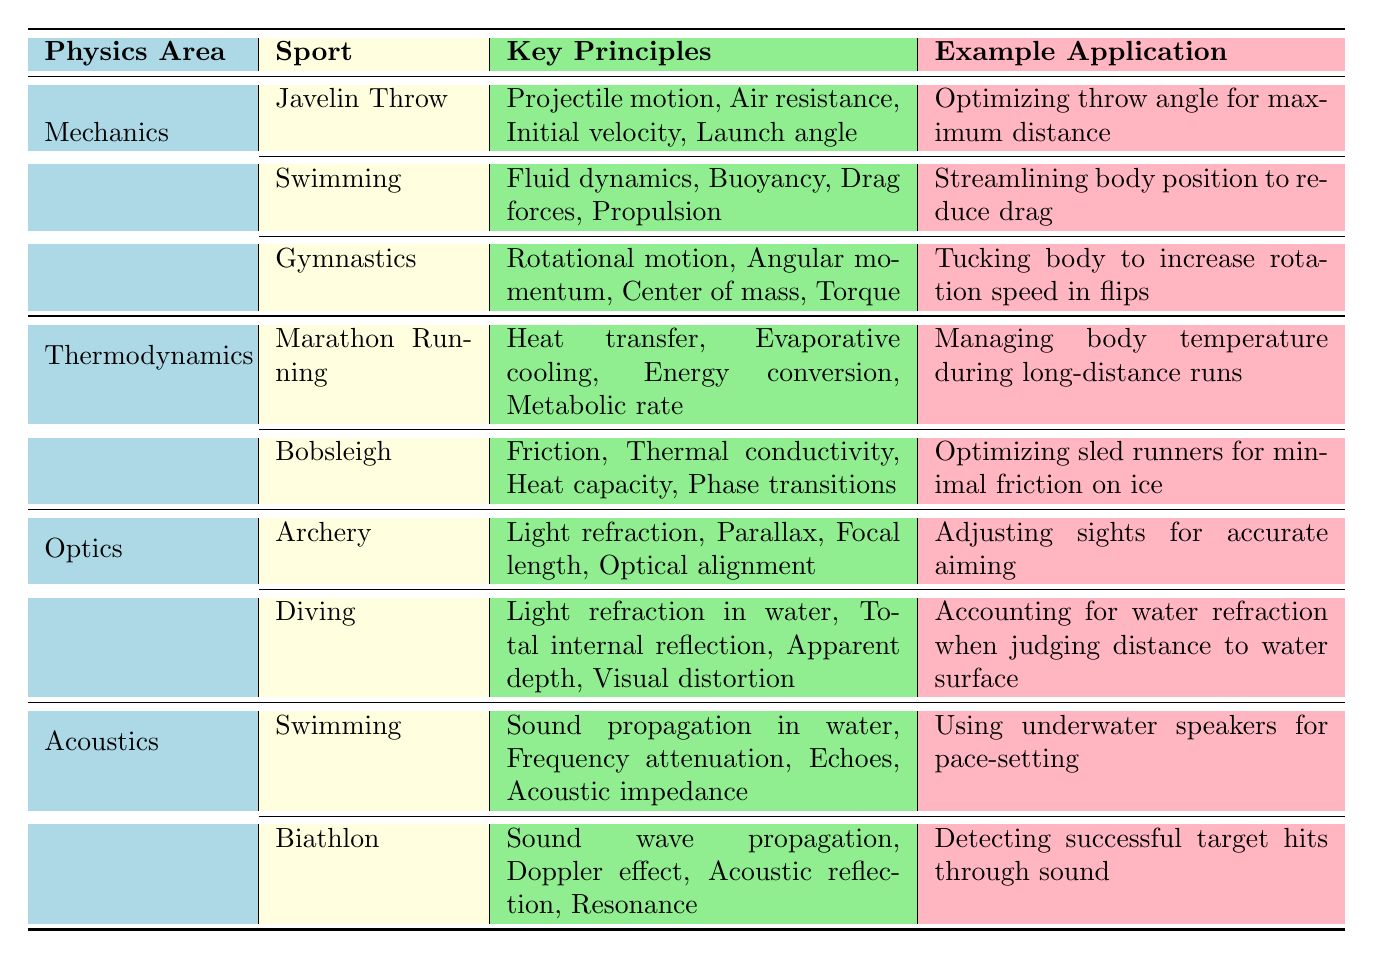What are the key principles involved in the Javelin Throw? The table lists the Javelin Throw under the Mechanics category and specifies its key principles as projectile motion, air resistance, initial velocity, and launch angle.
Answer: Projectile motion, air resistance, initial velocity, launch angle Which sport uses the principle of light refraction? The table indicates that Archery and Diving are listed under the Optics category, which includes light refraction as one of their key principles.
Answer: Archery and Diving How many sports demonstrate the principles of thermodynamics? From the table, there are two sports listed under the Thermodynamics category: Marathon Running and Bobsleigh, which counts as 2 sports.
Answer: 2 What is the application of managing body temperature during long-distance runs? The table shows that Marathon Running is linked with the application of managing body temperature during long-distance runs as part of the thermodynamics principles.
Answer: Managing body temperature Is fluid dynamics a principle used in swimming? The table confirms that swimming is listed under Mechanics and includes fluid dynamics as one of its key principles, affirming that it is indeed used in swimming.
Answer: Yes Which sport has the most physics principles associated with it and what are they? Upon reviewing the table, Swimming appears twice (once in Mechanics and once in Acoustics), but only has four principles listed in each instance. No sport has more than four principles associated with it. Thus, the answer is based on the data given for each instance of swimming or any sport with four principles.
Answer: No sport has more than four principles Which two sports both include the principle of sound propagation in their applications? The table shows that Swimming and Biathlon are both associated with sound propagation. Swimming includes it under acoustics, and Biathlon includes it as one of its key principles.
Answer: Swimming and Biathlon What principle is primarily used in Olympic Gymnastics to increase rotation speed in flips? Gymnastics involves the principle of rotational motion, and the application mentioned is tucking the body to increase rotation speed during flips.
Answer: Rotational motion What is the relationship between buoyancy and the sport of Swimming? The table indicates that Swimming is associated with buoyancy as one of its key principles under Mechanics, highlighting the relationship as significant for improving performance in the sport.
Answer: Significant relationship How many key principles does Bobsleigh have, and what is one of them? The table lists Bobsleigh under Thermodynamics with four key principles: friction, thermal conductivity, heat capacity, and phase transitions. So, it has a total of four principles.
Answer: 4 principles; one is friction 